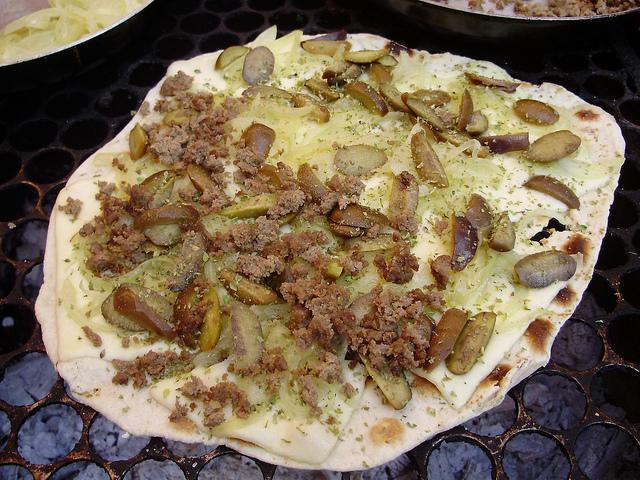How many bowls are there?
Give a very brief answer. 2. How many pizzas are in the picture?
Give a very brief answer. 1. 